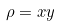Convert formula to latex. <formula><loc_0><loc_0><loc_500><loc_500>\rho = x y</formula> 